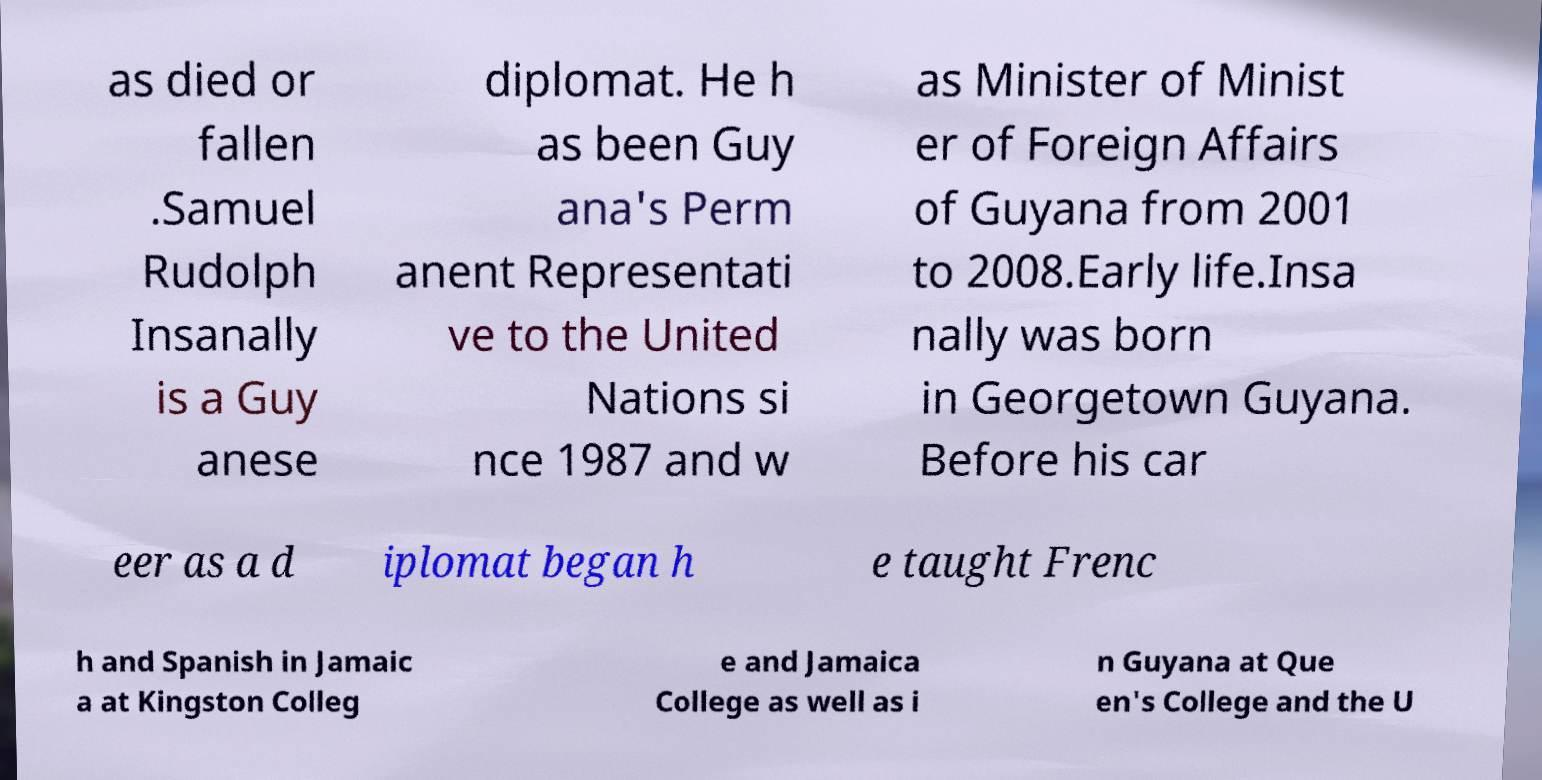What messages or text are displayed in this image? I need them in a readable, typed format. as died or fallen .Samuel Rudolph Insanally is a Guy anese diplomat. He h as been Guy ana's Perm anent Representati ve to the United Nations si nce 1987 and w as Minister of Minist er of Foreign Affairs of Guyana from 2001 to 2008.Early life.Insa nally was born in Georgetown Guyana. Before his car eer as a d iplomat began h e taught Frenc h and Spanish in Jamaic a at Kingston Colleg e and Jamaica College as well as i n Guyana at Que en's College and the U 